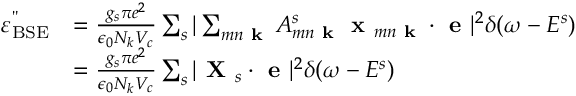Convert formula to latex. <formula><loc_0><loc_0><loc_500><loc_500>\begin{array} { r l } { \varepsilon _ { B S E } ^ { " } } & { = \frac { g _ { s } \pi e ^ { 2 } } { \epsilon _ { 0 } N _ { k } V _ { c } } \sum _ { s } | \sum _ { m n k } A _ { m n k } ^ { s } x _ { m n k } \cdot e | ^ { 2 } \delta ( \omega - E ^ { s } ) } \\ & { = \frac { g _ { s } \pi e ^ { 2 } } { \epsilon _ { 0 } N _ { k } V _ { c } } \sum _ { s } | X _ { s } \cdot e | ^ { 2 } \delta ( \omega - E ^ { s } ) } \end{array}</formula> 